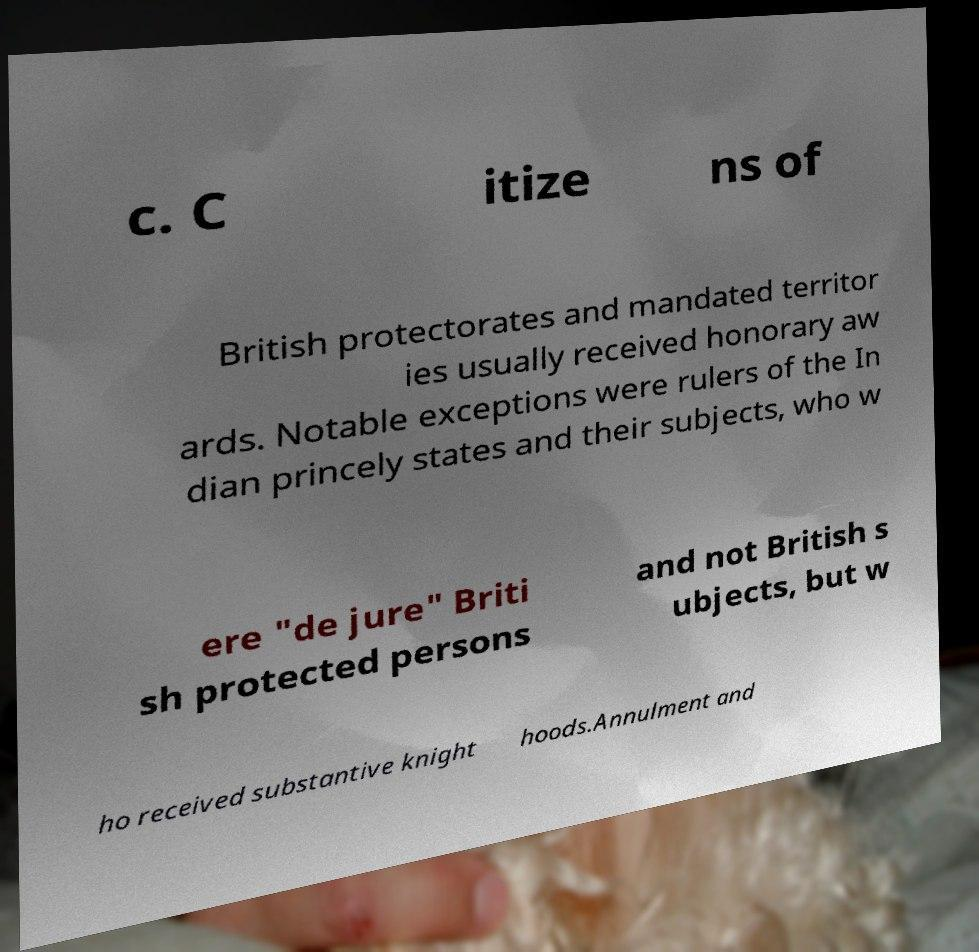Could you extract and type out the text from this image? c. C itize ns of British protectorates and mandated territor ies usually received honorary aw ards. Notable exceptions were rulers of the In dian princely states and their subjects, who w ere "de jure" Briti sh protected persons and not British s ubjects, but w ho received substantive knight hoods.Annulment and 